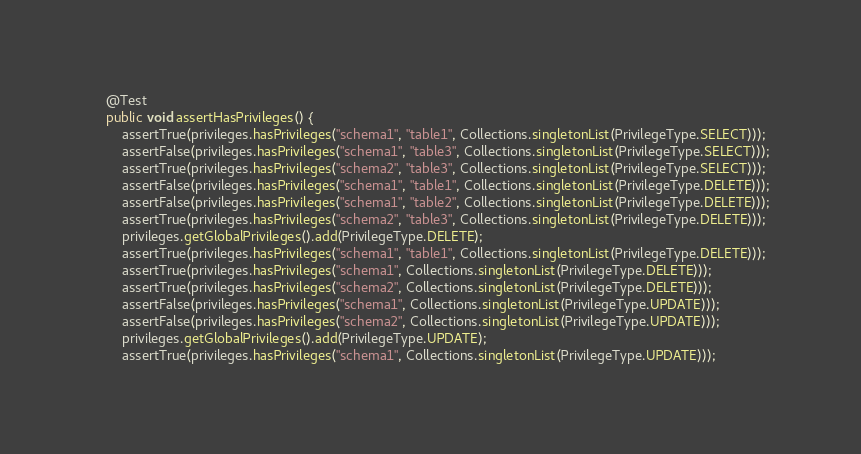Convert code to text. <code><loc_0><loc_0><loc_500><loc_500><_Java_>    @Test
    public void assertHasPrivileges() {
        assertTrue(privileges.hasPrivileges("schema1", "table1", Collections.singletonList(PrivilegeType.SELECT)));
        assertFalse(privileges.hasPrivileges("schema1", "table3", Collections.singletonList(PrivilegeType.SELECT)));
        assertTrue(privileges.hasPrivileges("schema2", "table3", Collections.singletonList(PrivilegeType.SELECT)));
        assertFalse(privileges.hasPrivileges("schema1", "table1", Collections.singletonList(PrivilegeType.DELETE)));
        assertFalse(privileges.hasPrivileges("schema1", "table2", Collections.singletonList(PrivilegeType.DELETE)));
        assertTrue(privileges.hasPrivileges("schema2", "table3", Collections.singletonList(PrivilegeType.DELETE)));
        privileges.getGlobalPrivileges().add(PrivilegeType.DELETE);
        assertTrue(privileges.hasPrivileges("schema1", "table1", Collections.singletonList(PrivilegeType.DELETE)));
        assertTrue(privileges.hasPrivileges("schema1", Collections.singletonList(PrivilegeType.DELETE)));
        assertTrue(privileges.hasPrivileges("schema2", Collections.singletonList(PrivilegeType.DELETE)));
        assertFalse(privileges.hasPrivileges("schema1", Collections.singletonList(PrivilegeType.UPDATE)));
        assertFalse(privileges.hasPrivileges("schema2", Collections.singletonList(PrivilegeType.UPDATE)));
        privileges.getGlobalPrivileges().add(PrivilegeType.UPDATE);
        assertTrue(privileges.hasPrivileges("schema1", Collections.singletonList(PrivilegeType.UPDATE)));</code> 